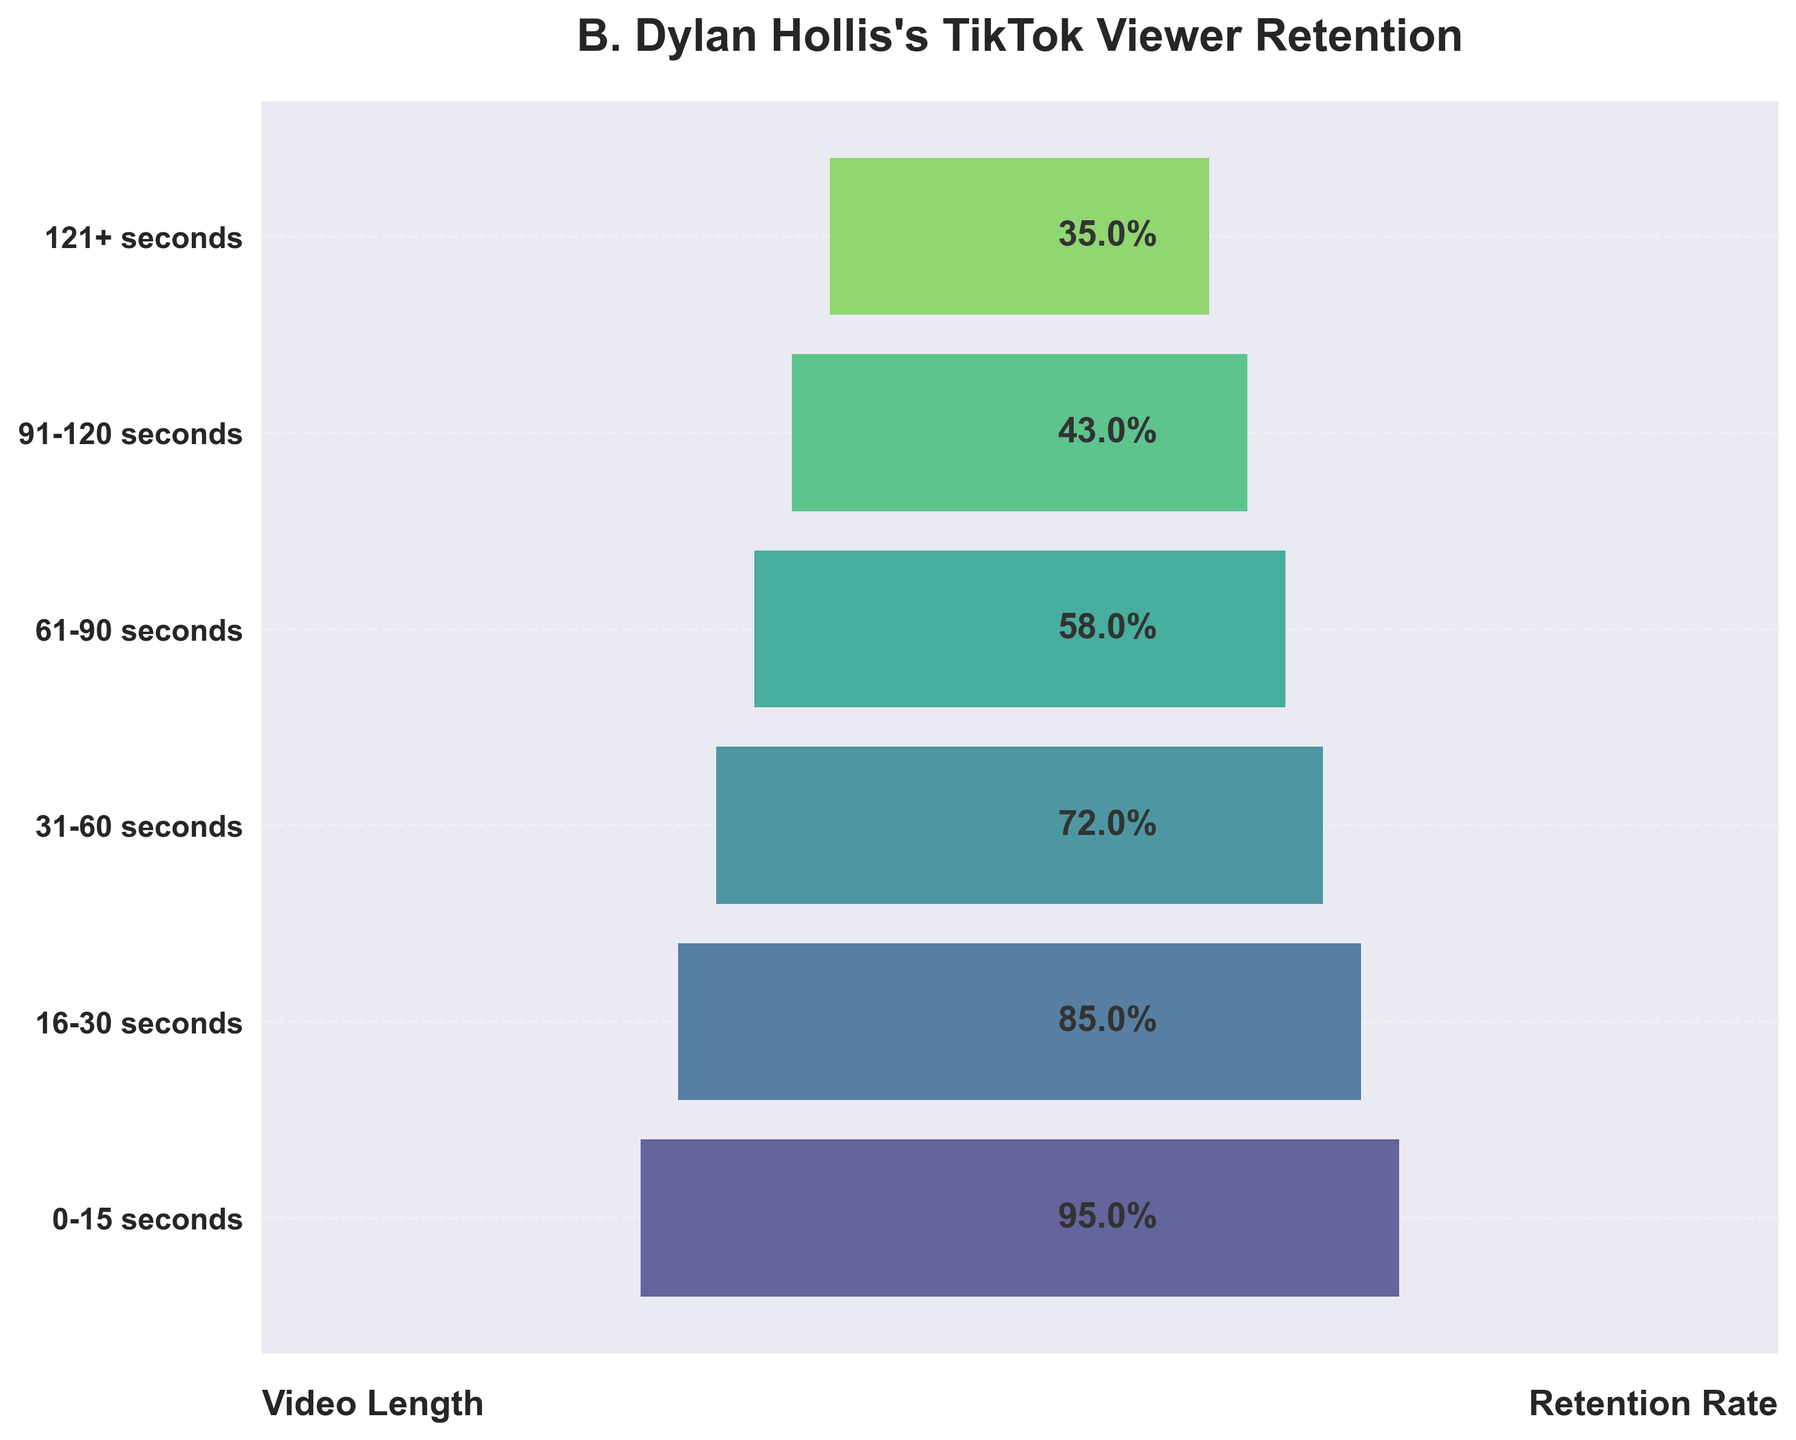what is the title of the figure? The title is at the top of the plot in bold and larger font size. It indicates the main context of the chart.
Answer: B. Dylan Hollis's TikTok Viewer Retention What is the viewer retention rate for videos that are 31-60 seconds long? The viewer retention rate for each video length is displayed as a percentage next to each bar on the horizontal axis. Find the percentage value next to the "31-60 seconds" label.
Answer: 72% How many different video length categories are presented in the chart? Count the number of distinct video length labels listed on the left y-axis.
Answer: 6 Which video length category has the highest viewer retention rate? Look at the percentage values beside each bar. The category with the highest percentage is the one with the highest viewer retention rate.
Answer: 0-15 seconds How does the viewer retention rate for videos that are 121+ seconds compare to those that are 91-120 seconds? Compare the percentage values next to the "121+ seconds" label and the "91-120 seconds" label.
Answer: Lower What is the difference in viewer retention rates between videos of 16-30 seconds and 61-90 seconds in length? Subtract the retention rate of 61-90 seconds from that of 16-30 seconds: 85% - 58% = 27%.
Answer: 27% Is there a general trend in viewer retention as video length increases? Examine the retention rates from shortest to longest video length. Observe if there is an increasing or decreasing trend.
Answer: Decreasing If the retention rate for a new category "11-25 seconds" is 90%, would it have a higher or lower retention than the existing categories? Compare the new retention rate of 90% with the existing retention rates in the funnel chart.
Answer: Higher What is the average viewer retention rate for all video length categories? Add all retention rates and divide by the number of categories: (95% + 85% + 72% + 58% + 43% + 35%) / 6 ≈ 64.67%.
Answer: 64.67% Which video length category shows the most significant drop in retention rate from the previous category? Calculate the differences between consecutive categories: (95% - 85%), (85% - 72%), (72% - 58%), (58% - 43%), (43% - 35%), and determine the largest value.
Answer: 18% (31-60 seconds to 61-90 seconds) 